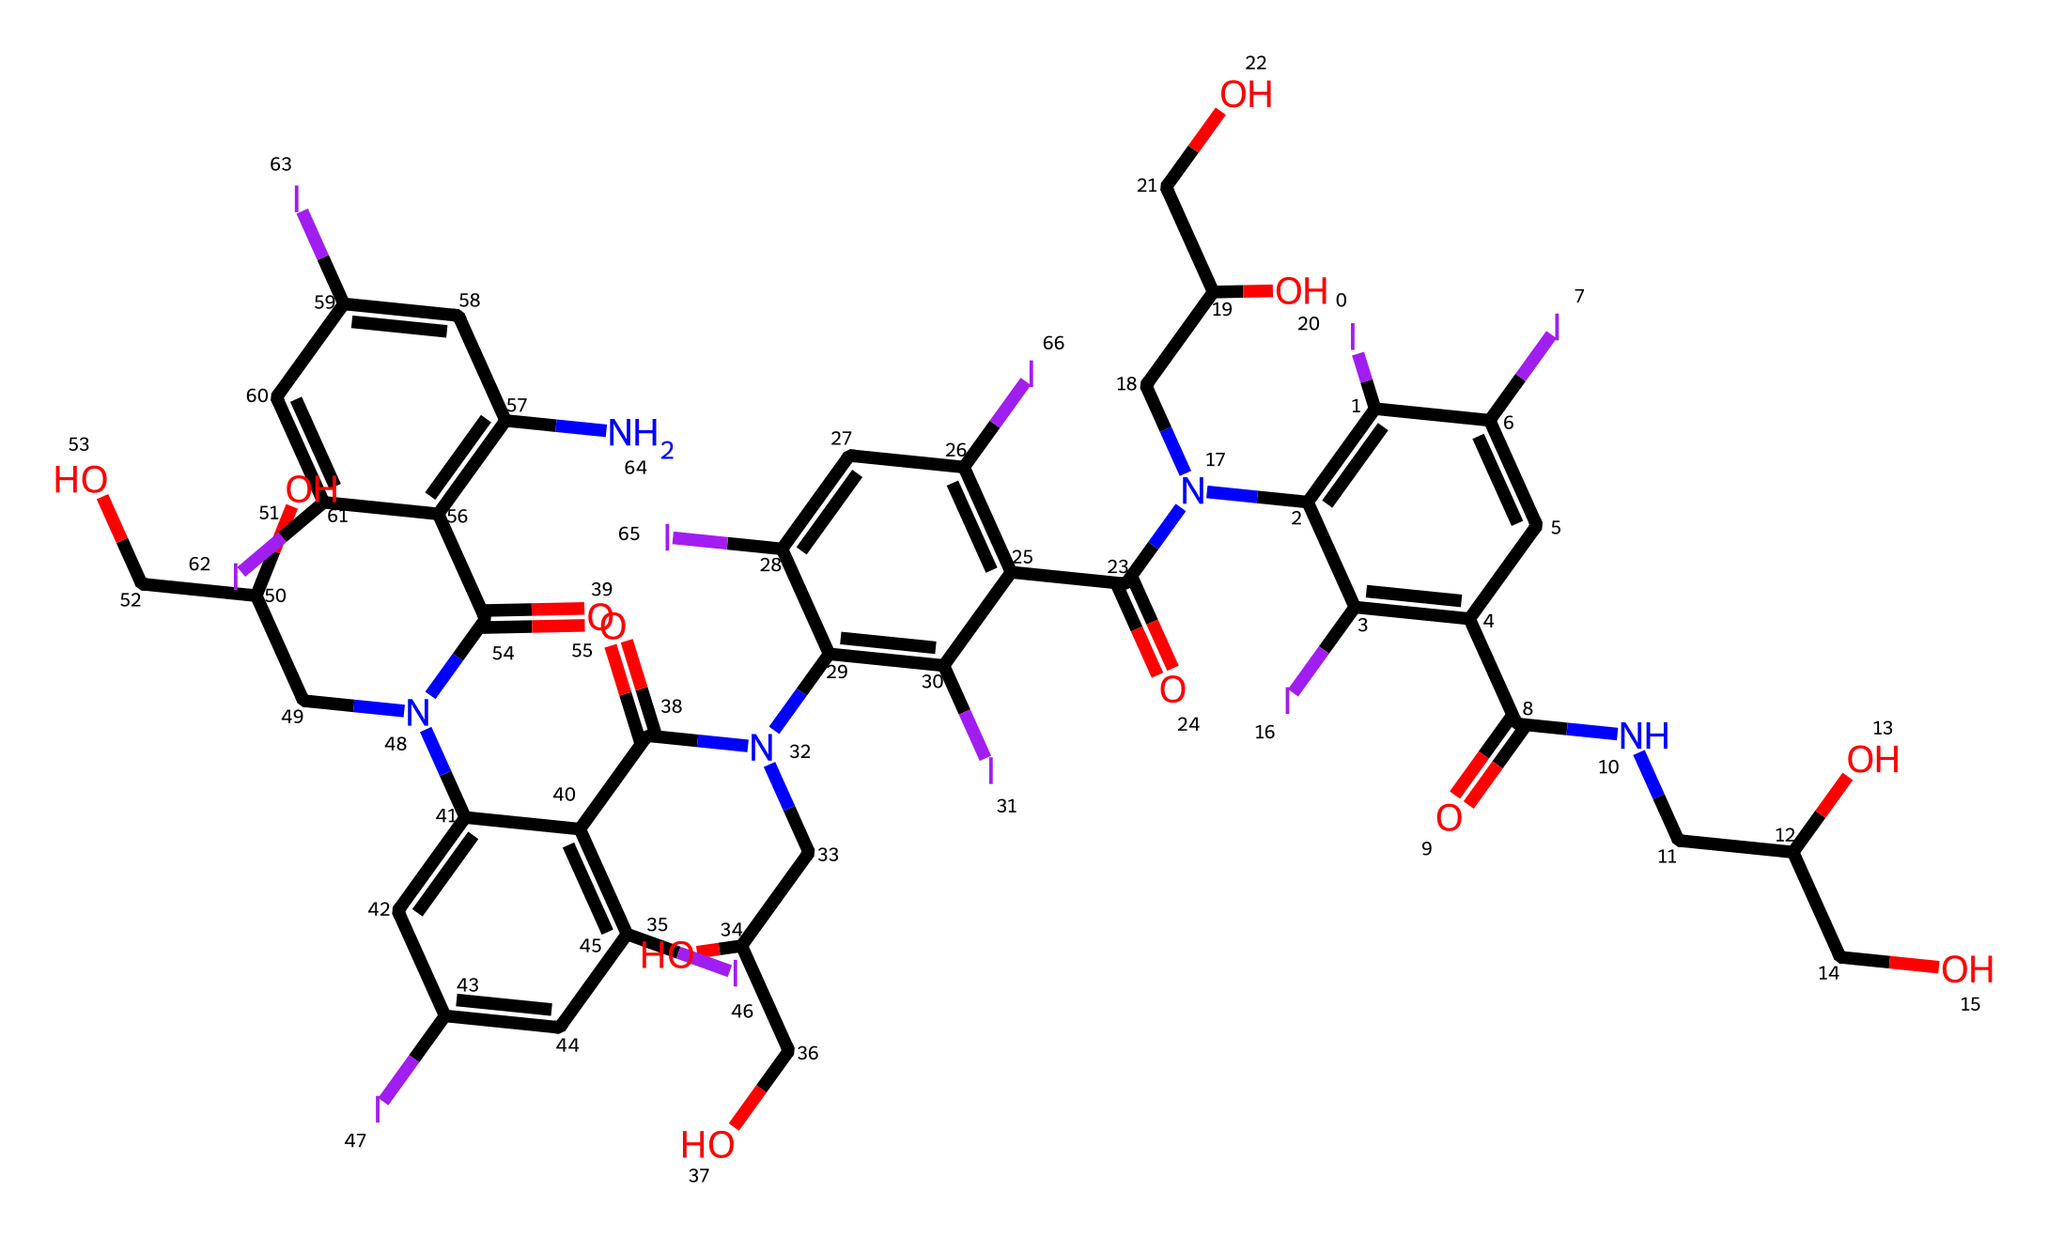What is the total number of iodine atoms in this structure? The structure can be analyzed by counting the number of iodine (I) symbols present in the SMILES representation. There are 8 instances of "I" in the provided SMILES.
Answer: 8 How many nitrogen atoms are present in this chemical? In the SMILES representation, the nitrogen atom is represented by "N." By reviewing the SMILES string, we see "N" appears 4 times, indicating there are 4 nitrogen atoms.
Answer: 4 What is the primary functional group in this structure? By examining the structure, we can identify the -C(=O)N- (amide) groups which are indicated by "C(=O)N" patterns in the string, confirming the presence of amides.
Answer: amide How does the presence of iodine affect the molecular weight of this compound? Iodine (I) atoms contribute significantly to the molecular weight due to their higher atomic mass compared to lighter elements. Since there are 8 iodines, their cumulative mass substantially increases the overall molecular weight.
Answer: increases Which type of bonding is primarily responsible for the stability of this chemical? The chemical's stability arises from covalent bonds, which are formed by the sharing of electrons between atoms, especially among carbon, nitrogen, and iodine atoms throughout the structure.
Answer: covalent Are there any carbonyl groups present in this chemical? A carbonyl group is characterized by a carbon double-bonded to oxygen (C=O). By inspecting the SMILES string, we can see multiple occurrences of C(=O), confirming the presence of these groups.
Answer: yes What is the significance of iodine in contrast agents for medical imaging? Iodine’s high atomic number provides excellent contrast in X-ray and CT imaging due to its ability to absorb X-rays effectively, enhancing visibility of the structures in medical imaging.
Answer: contrast agent 